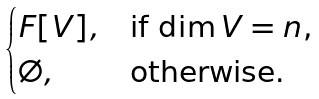Convert formula to latex. <formula><loc_0><loc_0><loc_500><loc_500>\begin{cases} F [ V ] , & \text {if $ \dim V=n$,} \\ \emptyset , & \text {otherwise.} \end{cases}</formula> 